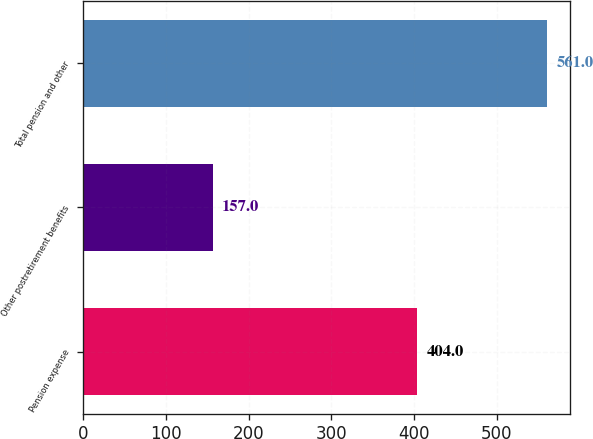Convert chart to OTSL. <chart><loc_0><loc_0><loc_500><loc_500><bar_chart><fcel>Pension expense<fcel>Other postretirement benefits<fcel>Total pension and other<nl><fcel>404<fcel>157<fcel>561<nl></chart> 